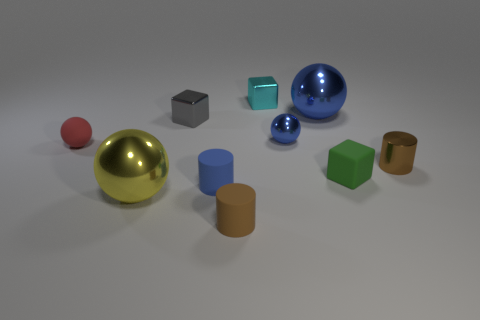Is the material of the tiny green cube the same as the tiny red sphere?
Your response must be concise. Yes. What number of blocks are either tiny gray metal objects or metallic things?
Give a very brief answer. 2. What is the color of the tiny metal thing behind the metallic block in front of the tiny cyan shiny thing?
Your response must be concise. Cyan. What is the size of the matte cylinder that is the same color as the tiny shiny cylinder?
Provide a succinct answer. Small. There is a brown object behind the ball that is in front of the small blue matte cylinder; what number of tiny blue rubber things are behind it?
Offer a terse response. 0. There is a rubber thing that is behind the green rubber thing; does it have the same shape as the small gray thing that is in front of the small cyan block?
Your response must be concise. No. What number of things are either big balls or tiny purple metal cylinders?
Keep it short and to the point. 2. What material is the brown thing behind the big ball that is in front of the tiny blue sphere made of?
Offer a very short reply. Metal. Are there any tiny things of the same color as the small metallic sphere?
Your response must be concise. Yes. There is another metallic ball that is the same size as the red ball; what is its color?
Your answer should be compact. Blue. 